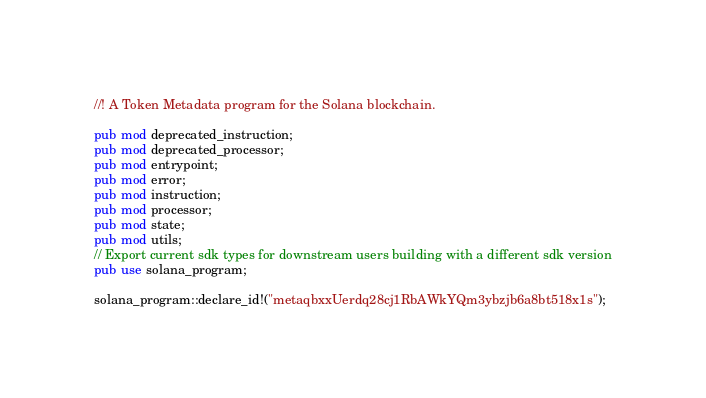<code> <loc_0><loc_0><loc_500><loc_500><_Rust_>//! A Token Metadata program for the Solana blockchain.

pub mod deprecated_instruction;
pub mod deprecated_processor;
pub mod entrypoint;
pub mod error;
pub mod instruction;
pub mod processor;
pub mod state;
pub mod utils;
// Export current sdk types for downstream users building with a different sdk version
pub use solana_program;

solana_program::declare_id!("metaqbxxUerdq28cj1RbAWkYQm3ybzjb6a8bt518x1s");
</code> 